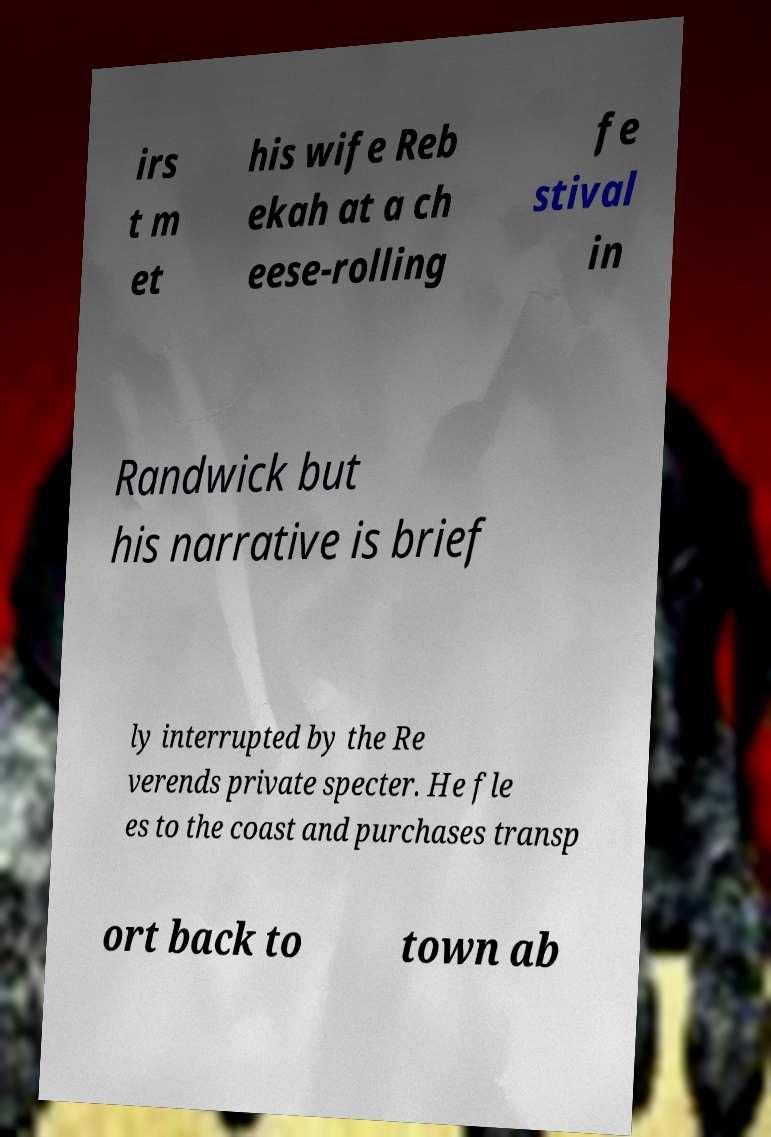Can you accurately transcribe the text from the provided image for me? irs t m et his wife Reb ekah at a ch eese-rolling fe stival in Randwick but his narrative is brief ly interrupted by the Re verends private specter. He fle es to the coast and purchases transp ort back to town ab 